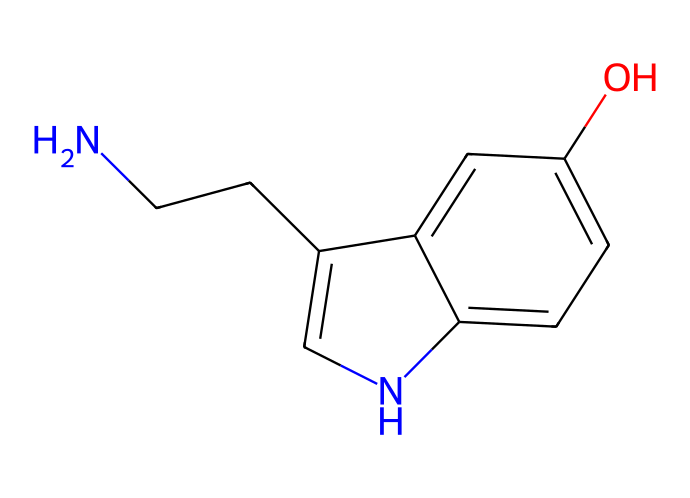What is the molecular formula of this chemical? To determine the molecular formula, we need to identify and count all the atoms present in the chemical structure represented by the SMILES. The elements present are carbon (C), hydrogen (H), nitrogen (N), and oxygen (O). By analyzing the structure, we find there are 10 carbons, 12 hydrogens, 1 nitrogen, and 1 oxygen. Therefore, the molecular formula is C10H12N2O.
Answer: C10H12N2O How many rings are present in this chemical structure? The structure can be analyzed to identify the number of cyclic (ring) components. In the given SMILES, there are two rings present, which can be visually confirmed by looking for closed loops in the structure. Thus, the answer is 2.
Answer: 2 What type of organic compound does this chemical represent? By examining the functional groups and the structure, we can draw conclusions about the general classification. The presence of an indole structure (indicated by the interconnected carbon and nitrogen cyclic components) and a hydroxy group indicates that this compound is an alkaloid.
Answer: alkaloid What is the significance of the hydroxyl group in this compound? The hydroxyl (-OH) group is indicative of alcohol functional groups, and it plays a crucial role in influencing the compound's solubility and reactivity. In serotonin, the hydroxyl group is involved in hydrogen bonding, which contributes to its function as a neurotransmitter affecting mood regulation.
Answer: neurotransmitter Does this chemical contain any nitrogen atoms? The structure can be analyzed for the presence of nitrogen atoms by locating the nitrogen symbols within the SMILES. There is one nitrogen atom present, which is significant since nitrogen is often involved in forming amines and is crucial in biological molecules like neurotransmitters.
Answer: yes Which part of the structure indicates its role in mood regulation? The presence of the indole moiety and the hydroxy group within the structure indicates its role in mood regulation. This structural configuration is characteristic of serotonin, a well-known neurotransmitter that influences mood and emotional states, making this compound significant for its regulatory functions.
Answer: indole moiety 